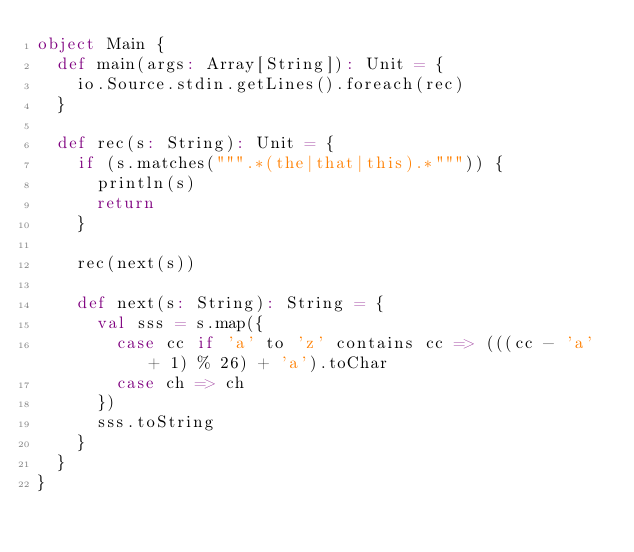Convert code to text. <code><loc_0><loc_0><loc_500><loc_500><_Scala_>object Main {
  def main(args: Array[String]): Unit = {
    io.Source.stdin.getLines().foreach(rec)
  }

  def rec(s: String): Unit = {
    if (s.matches(""".*(the|that|this).*""")) {
      println(s)
      return
    }

    rec(next(s))
    
    def next(s: String): String = {
      val sss = s.map({
        case cc if 'a' to 'z' contains cc => (((cc - 'a' + 1) % 26) + 'a').toChar
        case ch => ch
      })
      sss.toString
    }
  }
}</code> 